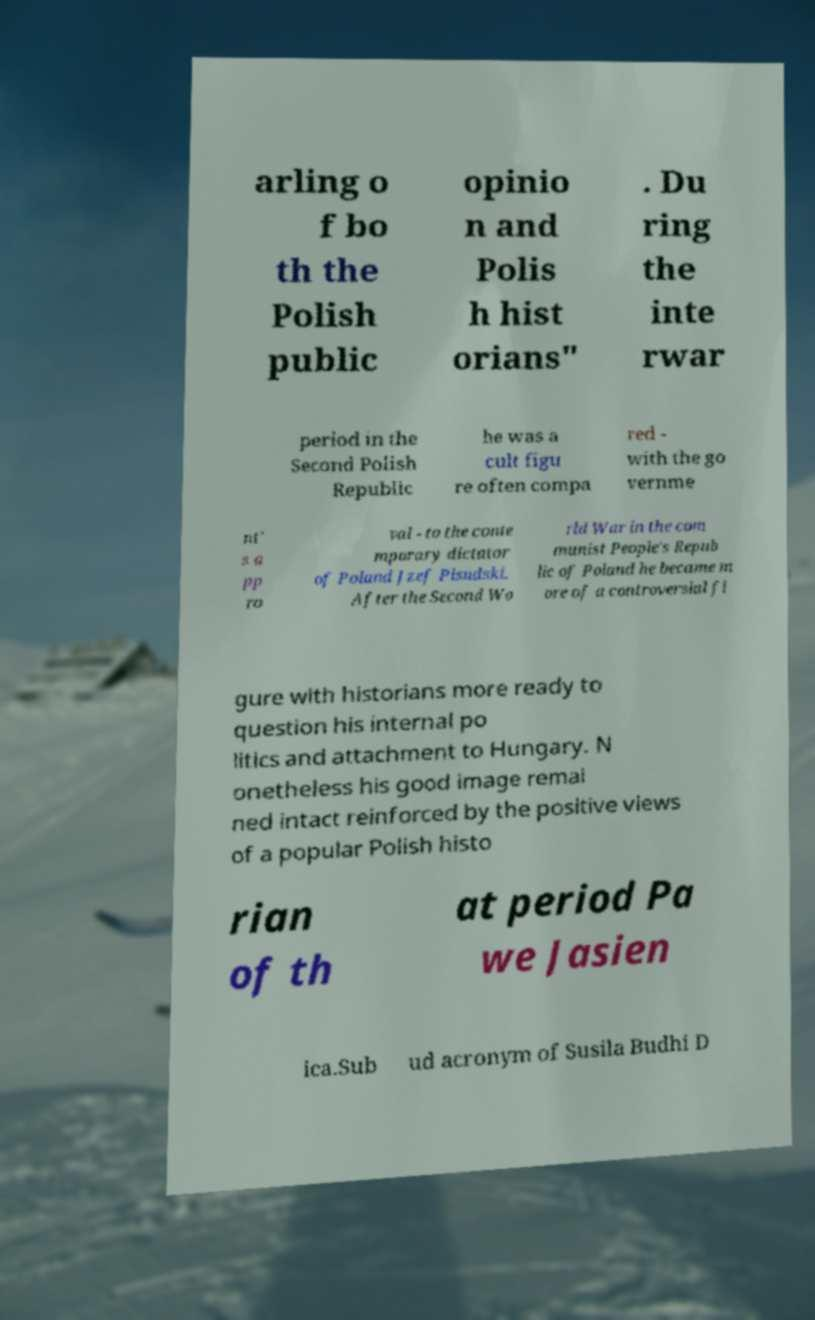Can you accurately transcribe the text from the provided image for me? arling o f bo th the Polish public opinio n and Polis h hist orians" . Du ring the inte rwar period in the Second Polish Republic he was a cult figu re often compa red - with the go vernme nt' s a pp ro val - to the conte mporary dictator of Poland Jzef Pisudski. After the Second Wo rld War in the com munist People's Repub lic of Poland he became m ore of a controversial fi gure with historians more ready to question his internal po litics and attachment to Hungary. N onetheless his good image remai ned intact reinforced by the positive views of a popular Polish histo rian of th at period Pa we Jasien ica.Sub ud acronym of Susila Budhi D 